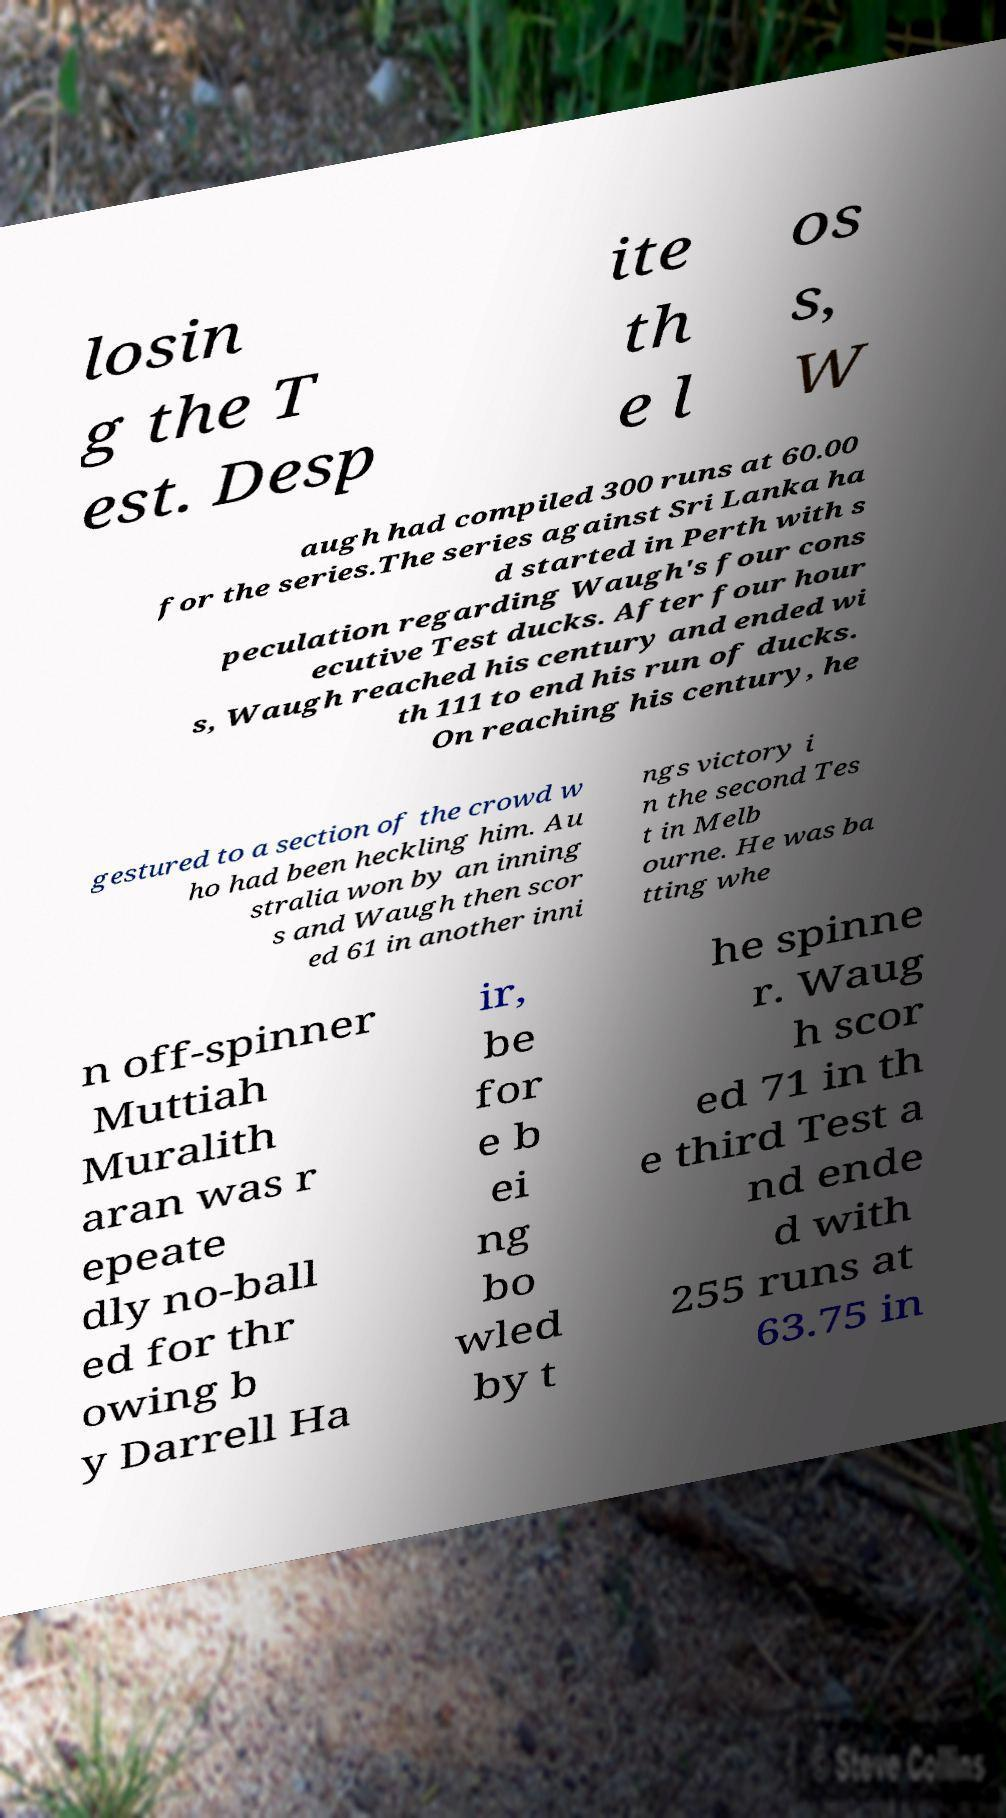Please identify and transcribe the text found in this image. losin g the T est. Desp ite th e l os s, W augh had compiled 300 runs at 60.00 for the series.The series against Sri Lanka ha d started in Perth with s peculation regarding Waugh's four cons ecutive Test ducks. After four hour s, Waugh reached his century and ended wi th 111 to end his run of ducks. On reaching his century, he gestured to a section of the crowd w ho had been heckling him. Au stralia won by an inning s and Waugh then scor ed 61 in another inni ngs victory i n the second Tes t in Melb ourne. He was ba tting whe n off-spinner Muttiah Muralith aran was r epeate dly no-ball ed for thr owing b y Darrell Ha ir, be for e b ei ng bo wled by t he spinne r. Waug h scor ed 71 in th e third Test a nd ende d with 255 runs at 63.75 in 